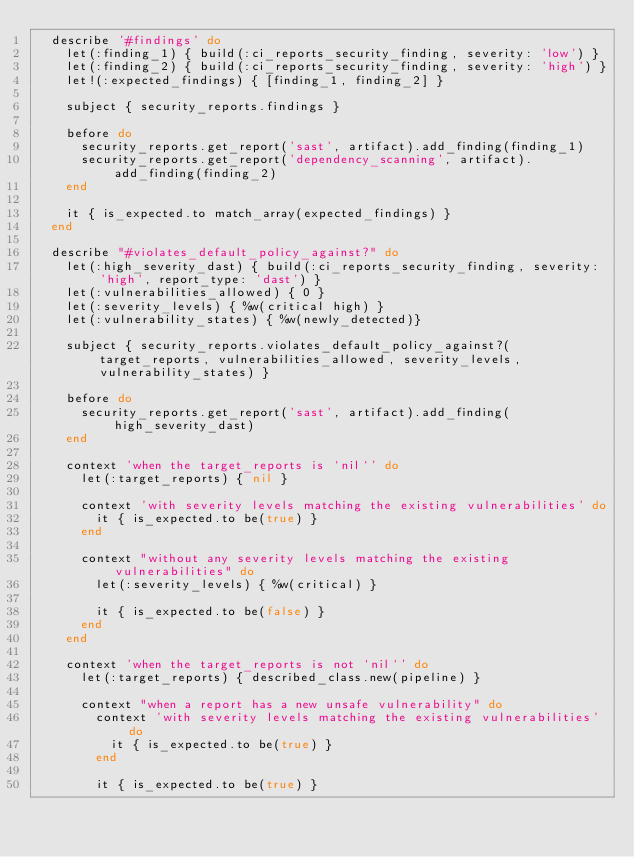<code> <loc_0><loc_0><loc_500><loc_500><_Ruby_>  describe '#findings' do
    let(:finding_1) { build(:ci_reports_security_finding, severity: 'low') }
    let(:finding_2) { build(:ci_reports_security_finding, severity: 'high') }
    let!(:expected_findings) { [finding_1, finding_2] }

    subject { security_reports.findings }

    before do
      security_reports.get_report('sast', artifact).add_finding(finding_1)
      security_reports.get_report('dependency_scanning', artifact).add_finding(finding_2)
    end

    it { is_expected.to match_array(expected_findings) }
  end

  describe "#violates_default_policy_against?" do
    let(:high_severity_dast) { build(:ci_reports_security_finding, severity: 'high', report_type: 'dast') }
    let(:vulnerabilities_allowed) { 0 }
    let(:severity_levels) { %w(critical high) }
    let(:vulnerability_states) { %w(newly_detected)}

    subject { security_reports.violates_default_policy_against?(target_reports, vulnerabilities_allowed, severity_levels, vulnerability_states) }

    before do
      security_reports.get_report('sast', artifact).add_finding(high_severity_dast)
    end

    context 'when the target_reports is `nil`' do
      let(:target_reports) { nil }

      context 'with severity levels matching the existing vulnerabilities' do
        it { is_expected.to be(true) }
      end

      context "without any severity levels matching the existing vulnerabilities" do
        let(:severity_levels) { %w(critical) }

        it { is_expected.to be(false) }
      end
    end

    context 'when the target_reports is not `nil`' do
      let(:target_reports) { described_class.new(pipeline) }

      context "when a report has a new unsafe vulnerability" do
        context 'with severity levels matching the existing vulnerabilities' do
          it { is_expected.to be(true) }
        end

        it { is_expected.to be(true) }
</code> 